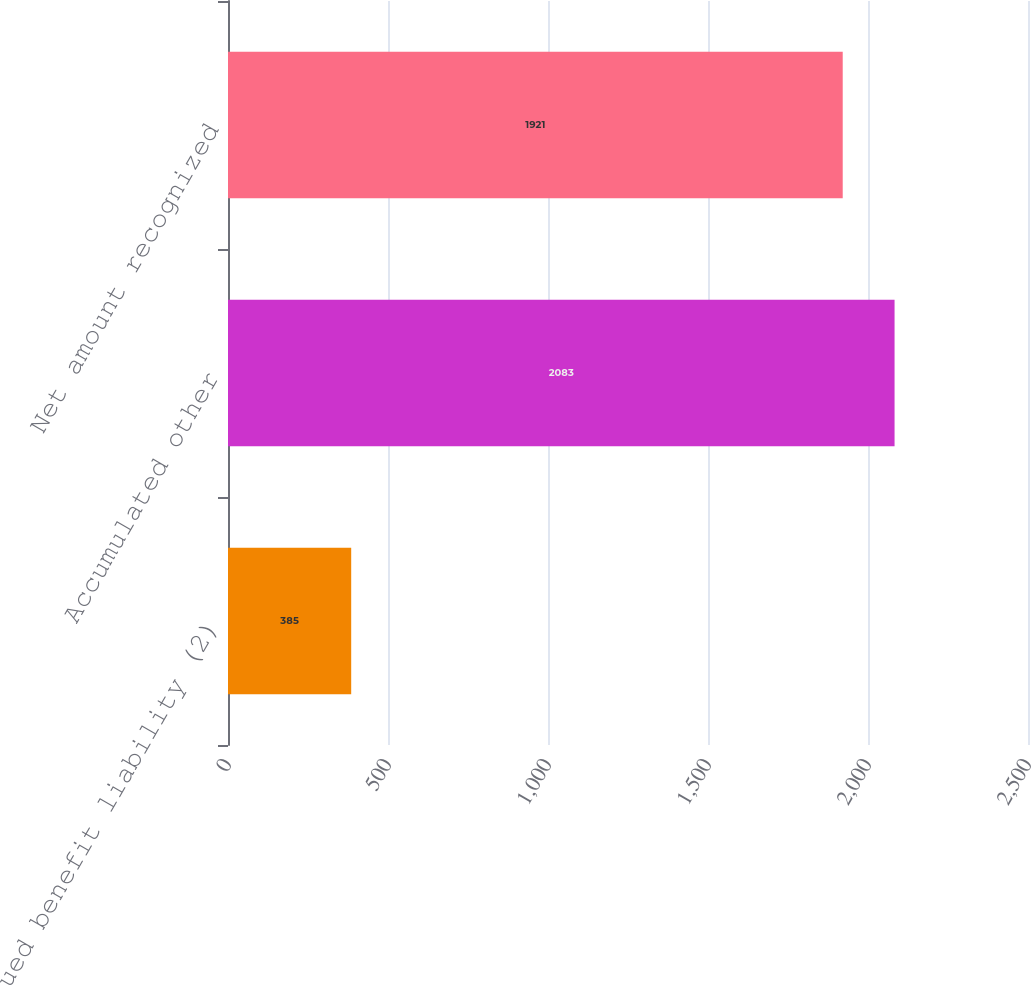<chart> <loc_0><loc_0><loc_500><loc_500><bar_chart><fcel>Accrued benefit liability (2)<fcel>Accumulated other<fcel>Net amount recognized<nl><fcel>385<fcel>2083<fcel>1921<nl></chart> 